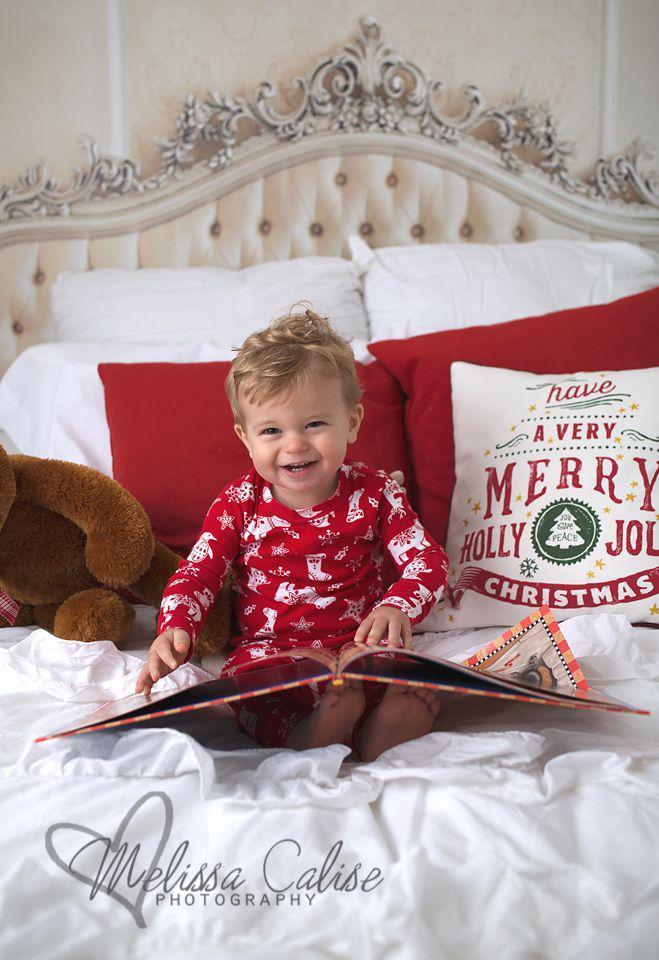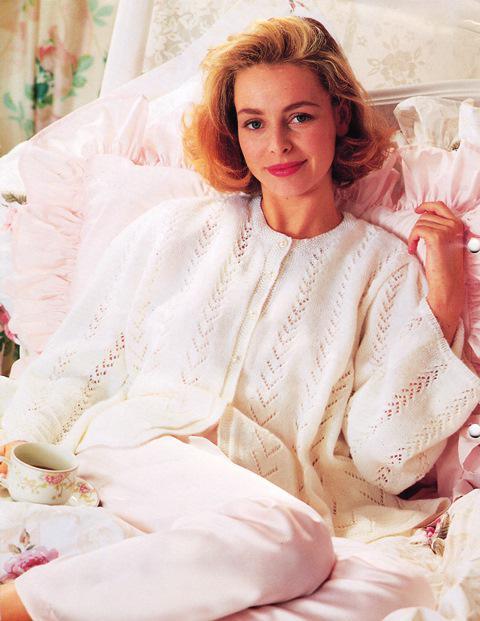The first image is the image on the left, the second image is the image on the right. Assess this claim about the two images: "In one of the pictures, there is a smiling child with a stuffed animal near it, and in the other picture there is a woman alone.". Correct or not? Answer yes or no. Yes. The first image is the image on the left, the second image is the image on the right. Analyze the images presented: Is the assertion "An image shows a child in sleepwear near a stuffed animal, with no adult present." valid? Answer yes or no. Yes. 